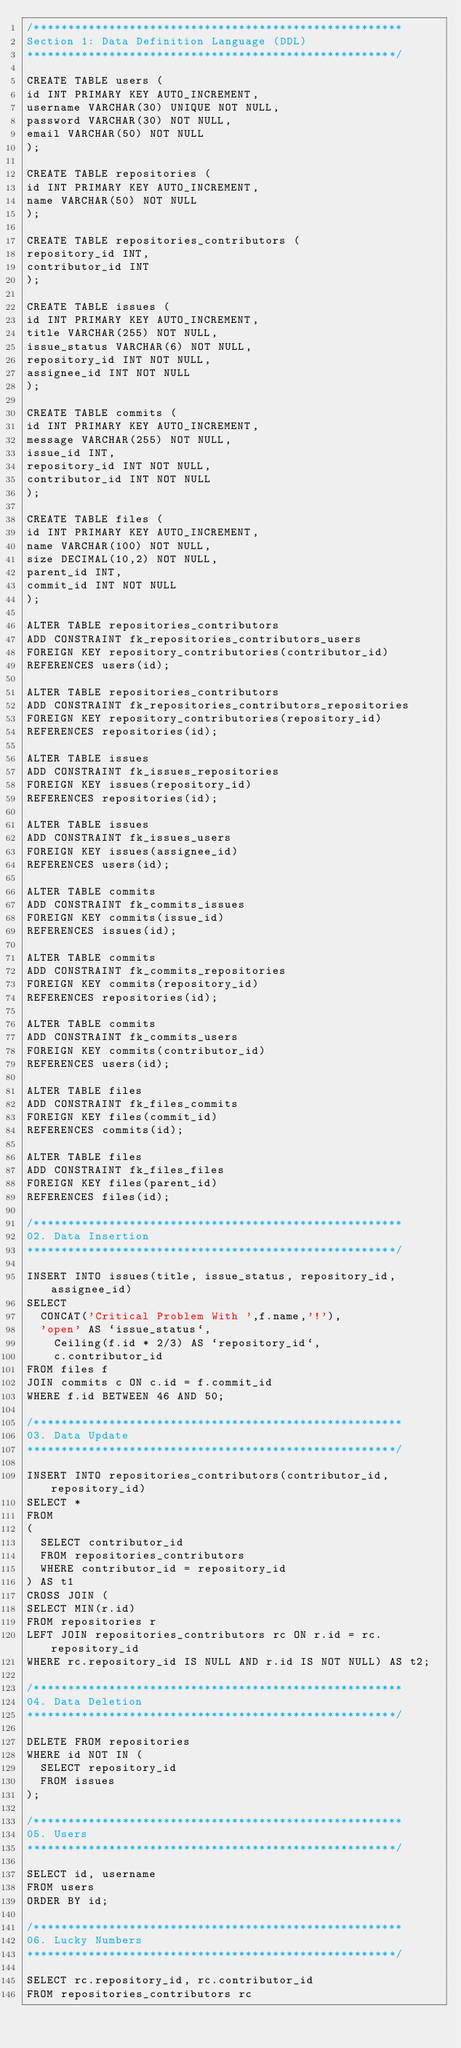<code> <loc_0><loc_0><loc_500><loc_500><_SQL_>/******************************************************
Section 1: Data Definition Language (DDL)
******************************************************/

CREATE TABLE users (
id INT PRIMARY KEY AUTO_INCREMENT,
username VARCHAR(30) UNIQUE NOT NULL,
password VARCHAR(30) NOT NULL,
email VARCHAR(50) NOT NULL
);

CREATE TABLE repositories (
id INT PRIMARY KEY AUTO_INCREMENT,
name VARCHAR(50) NOT NULL
);

CREATE TABLE repositories_contributors (
repository_id INT,
contributor_id INT 
);

CREATE TABLE issues (
id INT PRIMARY KEY AUTO_INCREMENT,
title VARCHAR(255) NOT NULL,
issue_status VARCHAR(6) NOT NULL,
repository_id INT NOT NULL,
assignee_id INT NOT NULL
);

CREATE TABLE commits (
id INT PRIMARY KEY AUTO_INCREMENT,
message VARCHAR(255) NOT NULL,
issue_id INT,
repository_id INT NOT NULL,
contributor_id INT NOT NULL
);

CREATE TABLE files (
id INT PRIMARY KEY AUTO_INCREMENT,
name VARCHAR(100) NOT NULL,
size DECIMAL(10,2) NOT NULL,
parent_id INT,
commit_id INT NOT NULL
);

ALTER TABLE repositories_contributors
ADD CONSTRAINT fk_repositories_contributors_users
FOREIGN KEY repository_contributories(contributor_id) 
REFERENCES users(id);

ALTER TABLE repositories_contributors
ADD CONSTRAINT fk_repositories_contributors_repositories
FOREIGN KEY repository_contributories(repository_id) 
REFERENCES repositories(id);

ALTER TABLE issues
ADD CONSTRAINT fk_issues_repositories
FOREIGN KEY issues(repository_id) 
REFERENCES repositories(id);

ALTER TABLE issues
ADD CONSTRAINT fk_issues_users
FOREIGN KEY issues(assignee_id) 
REFERENCES users(id);

ALTER TABLE commits
ADD CONSTRAINT fk_commits_issues
FOREIGN KEY commits(issue_id) 
REFERENCES issues(id);

ALTER TABLE commits
ADD CONSTRAINT fk_commits_repositories
FOREIGN KEY commits(repository_id) 
REFERENCES repositories(id);

ALTER TABLE commits
ADD CONSTRAINT fk_commits_users
FOREIGN KEY commits(contributor_id) 
REFERENCES users(id);

ALTER TABLE files
ADD CONSTRAINT fk_files_commits
FOREIGN KEY files(commit_id) 
REFERENCES commits(id);

ALTER TABLE files
ADD CONSTRAINT fk_files_files
FOREIGN KEY files(parent_id) 
REFERENCES files(id);

/******************************************************
02.	Data Insertion
******************************************************/

INSERT INTO issues(title, issue_status, repository_id, assignee_id)
SELECT 
	CONCAT('Critical Problem With ',f.name,'!'),
	'open' AS `issue_status`,
    Ceiling(f.id * 2/3) AS `repository_id`,
    c.contributor_id
FROM files f
JOIN commits c ON c.id = f.commit_id
WHERE f.id BETWEEN 46 AND 50;

/******************************************************
03.	Data Update
******************************************************/

INSERT INTO repositories_contributors(contributor_id, repository_id)
SELECT *
FROM 
(
	SELECT contributor_id
	FROM repositories_contributors
	WHERE contributor_id = repository_id
) AS t1
CROSS JOIN (
SELECT MIN(r.id)
FROM repositories r
LEFT JOIN repositories_contributors rc ON r.id = rc.repository_id
WHERE rc.repository_id IS NULL AND r.id IS NOT NULL) AS t2;

/******************************************************
04.	Data Deletion
******************************************************/

DELETE FROM repositories
WHERE id NOT IN (
	SELECT repository_id 
	FROM issues
);

/******************************************************
05.	Users
******************************************************/

SELECT id, username
FROM users
ORDER BY id;

/******************************************************
06.	Lucky Numbers
******************************************************/

SELECT rc.repository_id, rc.contributor_id
FROM repositories_contributors rc</code> 